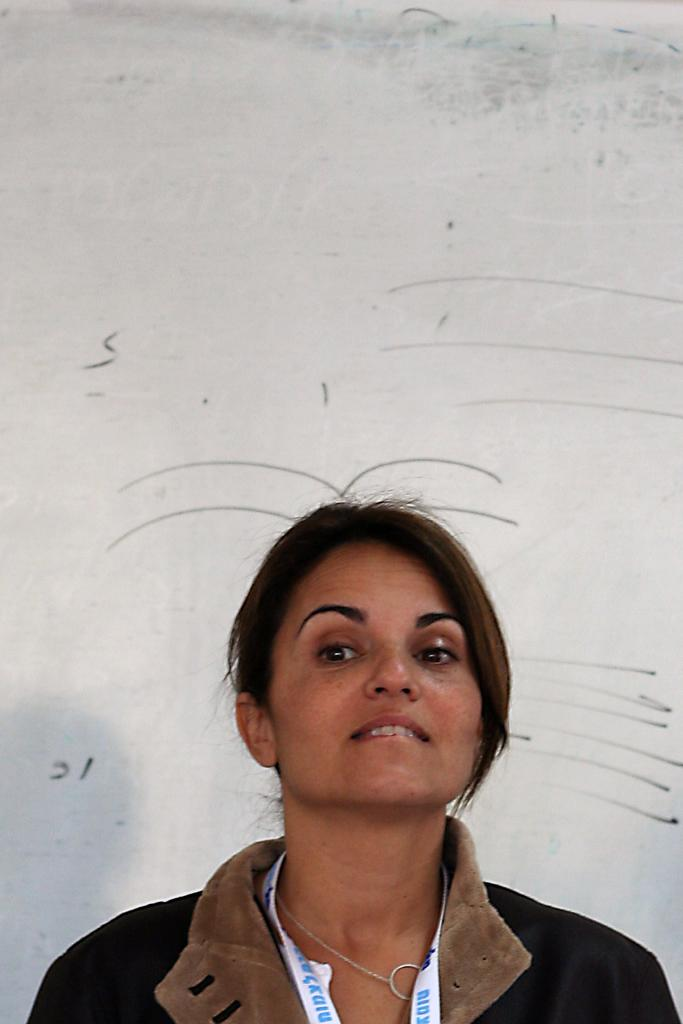Who is present in the image? There is a woman in the image. What is the woman wearing? The woman is wearing a jacket. Does the woman have any identification in the image? Yes, the woman has an identity card. What type of accessory is the woman wearing? The woman is wearing a chain. What can be seen in the background of the image? There is a wall in the background of the image, and there are drawings on the wall. How many wrists does the woman have in the image? The woman has two wrists in the image, as she is a human being. However, the number of wrists is not relevant to the image, as it does not focus on her wrists. What are the woman's hands doing in the image? The image does not show the woman's hands or their actions, so it cannot be determined from the image. 